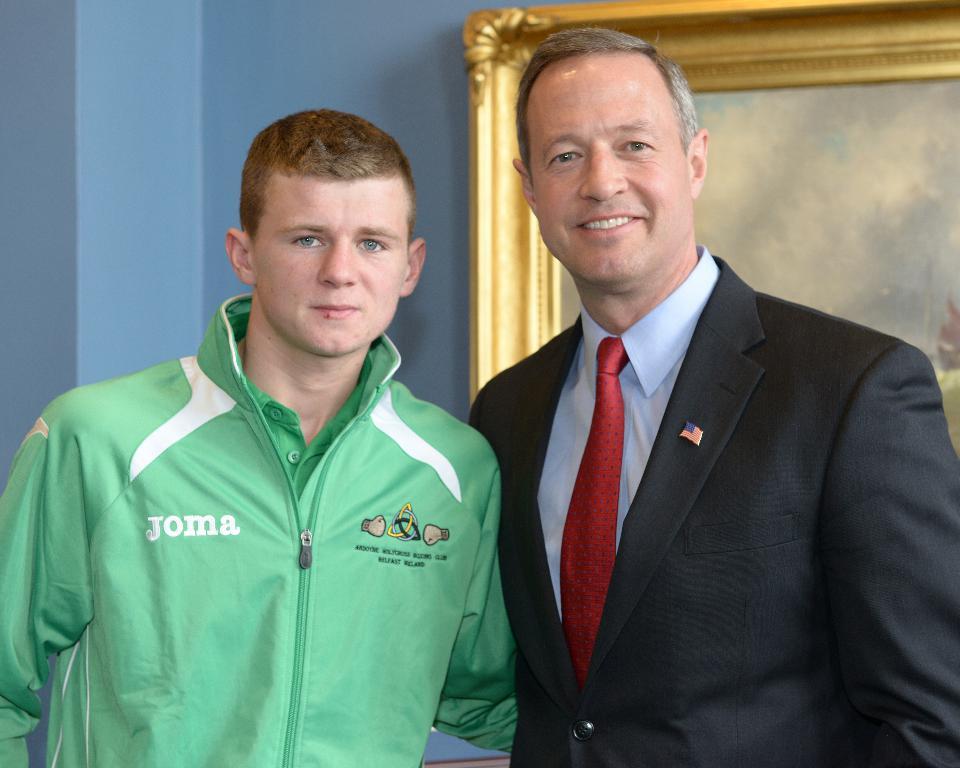What is the company name on the young man's jacket?
Your answer should be very brief. Joma. What country is on his jacket?
Keep it short and to the point. Ireland. 